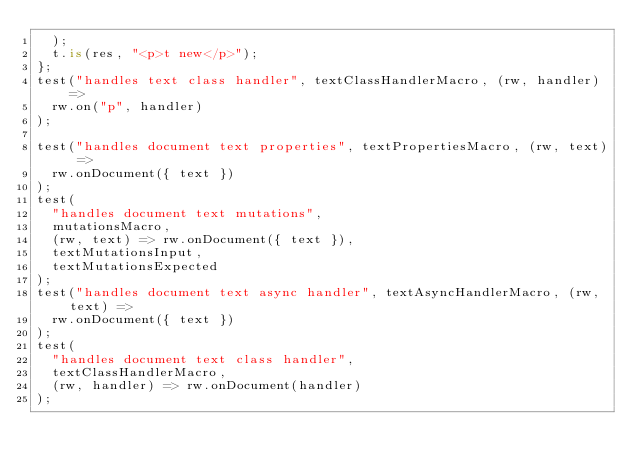Convert code to text. <code><loc_0><loc_0><loc_500><loc_500><_TypeScript_>  );
  t.is(res, "<p>t new</p>");
};
test("handles text class handler", textClassHandlerMacro, (rw, handler) =>
  rw.on("p", handler)
);

test("handles document text properties", textPropertiesMacro, (rw, text) =>
  rw.onDocument({ text })
);
test(
  "handles document text mutations",
  mutationsMacro,
  (rw, text) => rw.onDocument({ text }),
  textMutationsInput,
  textMutationsExpected
);
test("handles document text async handler", textAsyncHandlerMacro, (rw, text) =>
  rw.onDocument({ text })
);
test(
  "handles document text class handler",
  textClassHandlerMacro,
  (rw, handler) => rw.onDocument(handler)
);
</code> 